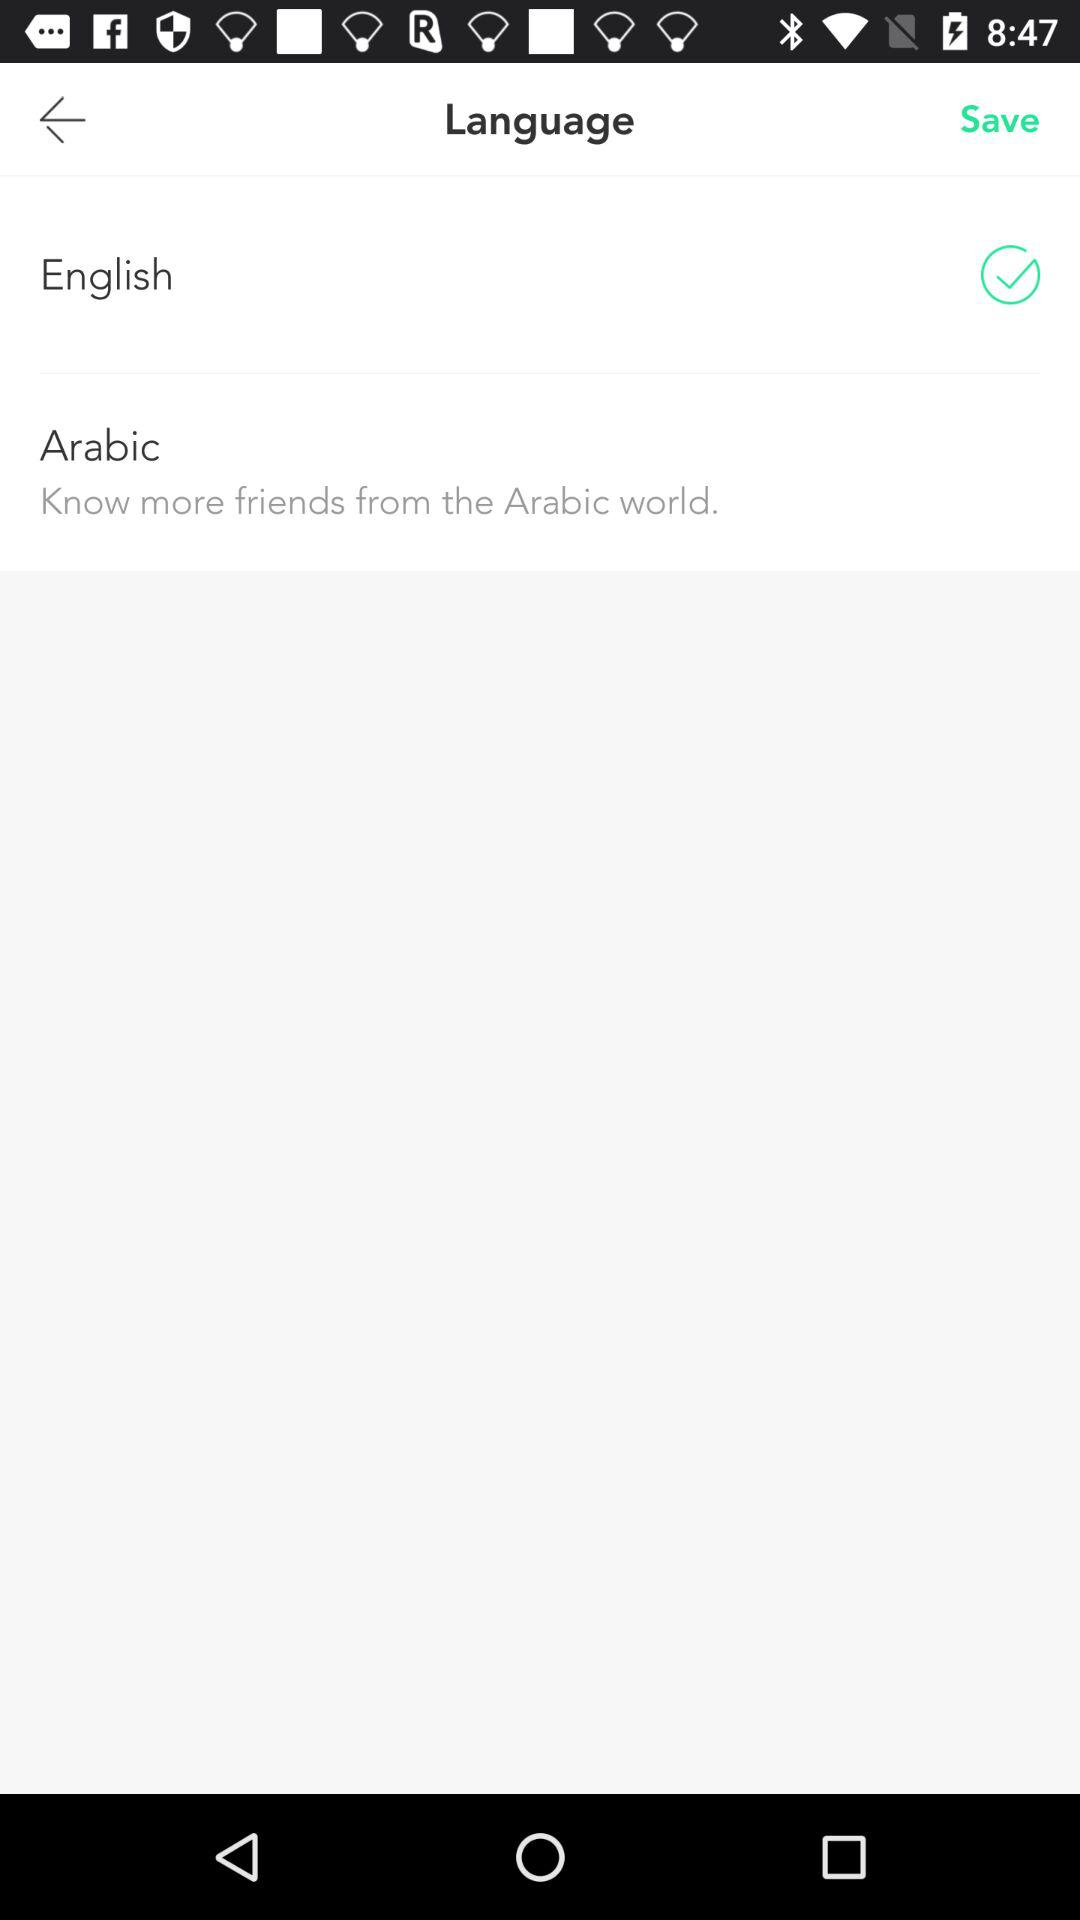How many languages are available to choose from?
Answer the question using a single word or phrase. 2 